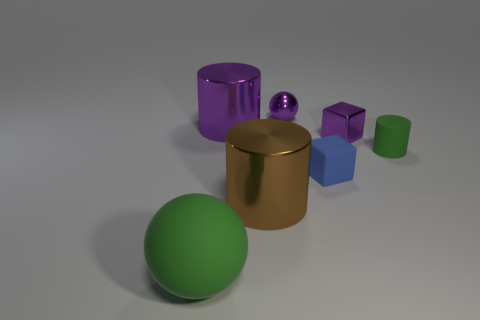Is the number of shiny balls that are right of the purple ball the same as the number of small red shiny blocks?
Offer a very short reply. Yes. Do the tiny block left of the shiny block and the green object behind the large green thing have the same material?
Offer a terse response. Yes. Do the large object behind the small rubber cylinder and the green object that is behind the large brown shiny cylinder have the same shape?
Ensure brevity in your answer.  Yes. Are there fewer large green matte objects that are behind the small green object than brown objects?
Your answer should be very brief. Yes. What number of big matte things have the same color as the small rubber cube?
Your response must be concise. 0. There is a ball behind the brown metal object; what size is it?
Give a very brief answer. Small. There is a tiny matte object left of the green matte thing behind the green rubber thing on the left side of the small green object; what is its shape?
Keep it short and to the point. Cube. There is a metal thing that is both in front of the large purple object and behind the tiny blue block; what is its shape?
Offer a terse response. Cube. Is there a red matte object of the same size as the brown metal thing?
Offer a terse response. No. Is the shape of the purple shiny thing that is in front of the purple cylinder the same as  the blue object?
Provide a short and direct response. Yes. 